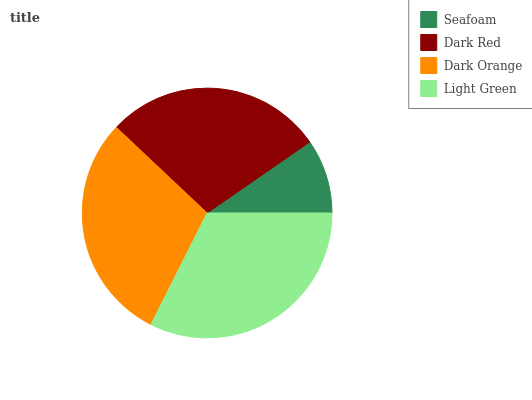Is Seafoam the minimum?
Answer yes or no. Yes. Is Light Green the maximum?
Answer yes or no. Yes. Is Dark Red the minimum?
Answer yes or no. No. Is Dark Red the maximum?
Answer yes or no. No. Is Dark Red greater than Seafoam?
Answer yes or no. Yes. Is Seafoam less than Dark Red?
Answer yes or no. Yes. Is Seafoam greater than Dark Red?
Answer yes or no. No. Is Dark Red less than Seafoam?
Answer yes or no. No. Is Dark Orange the high median?
Answer yes or no. Yes. Is Dark Red the low median?
Answer yes or no. Yes. Is Light Green the high median?
Answer yes or no. No. Is Dark Orange the low median?
Answer yes or no. No. 